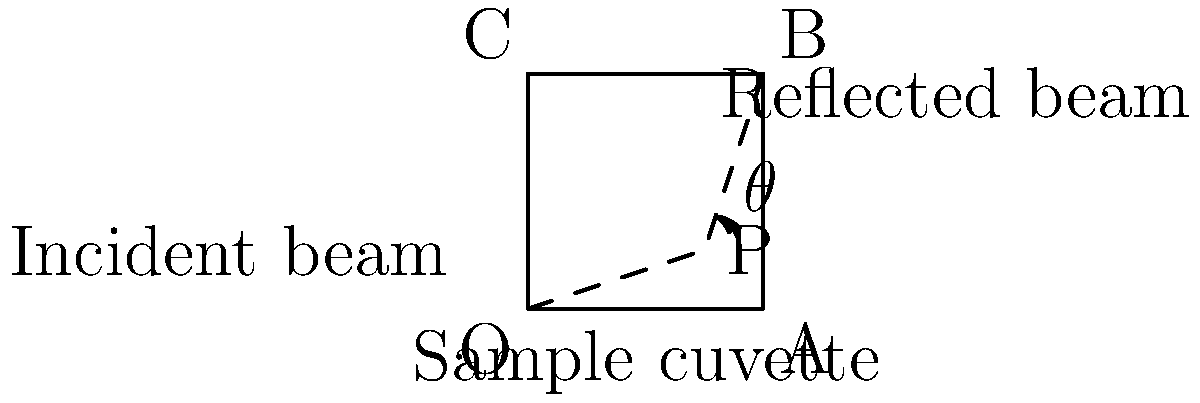In a spectrophotometric analysis of enzyme kinetics, the incident beam enters a sample cuvette at point P, as shown in the diagram. If the angle between the incident beam and the reflected beam is 90°, what is the angle of incidence (θ) for the light beam? To determine the angle of incidence (θ), we can follow these steps:

1. Recognize that the sample cuvette forms a right angle (90°) at point B.

2. Observe that the incident beam and reflected beam form a 90° angle, as stated in the question.

3. In a right-angled triangle, the sum of all angles is 180°.

4. The angle of incidence (θ) and the angle of reflection are equal according to the law of reflection.

5. Let x be the angle of reflection. Then we can set up the equation:
   $$ \theta + x + 90° = 180° $$

6. Since the angle of incidence equals the angle of reflection:
   $$ \theta = x $$

7. Substituting this into our equation:
   $$ \theta + \theta + 90° = 180° $$
   $$ 2\theta + 90° = 180° $$

8. Solve for θ:
   $$ 2\theta = 90° $$
   $$ \theta = 45° $$

Therefore, the angle of incidence (θ) is 45°.
Answer: 45° 